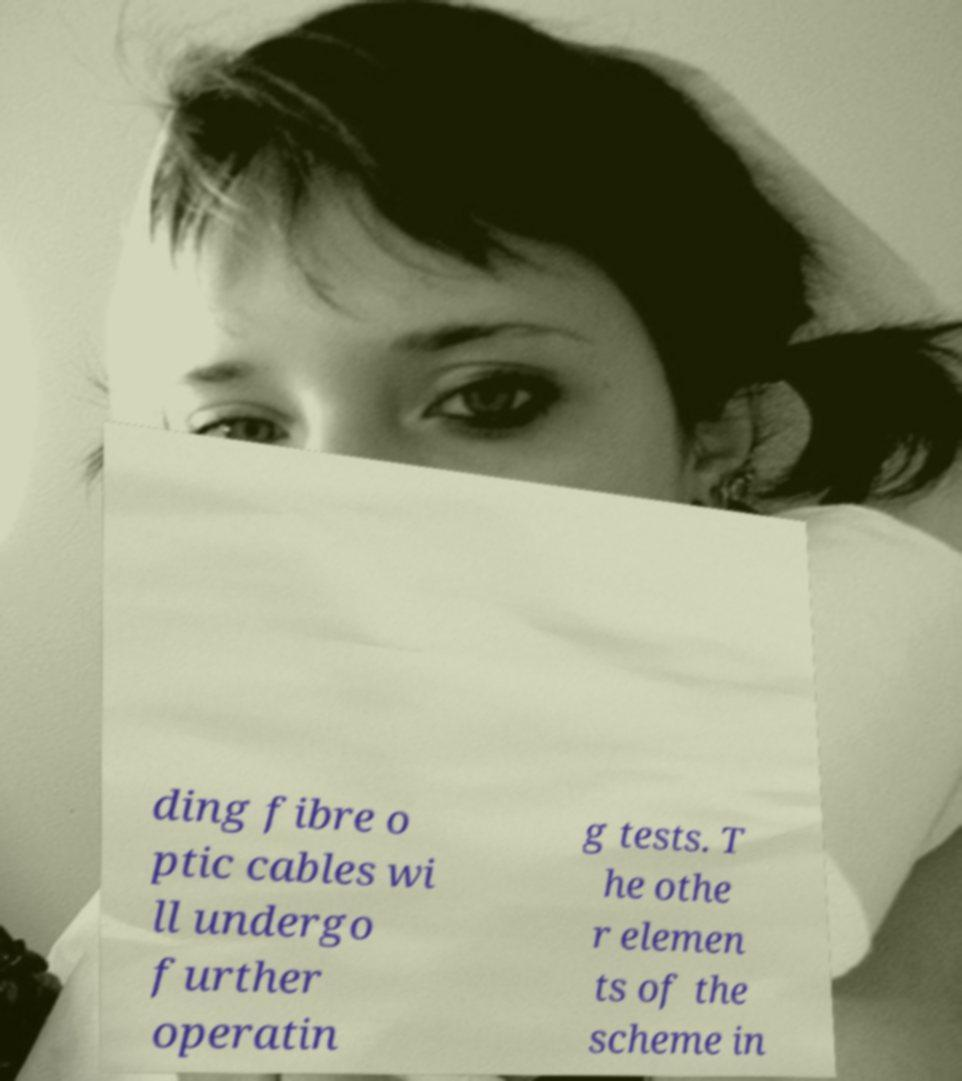Please identify and transcribe the text found in this image. ding fibre o ptic cables wi ll undergo further operatin g tests. T he othe r elemen ts of the scheme in 